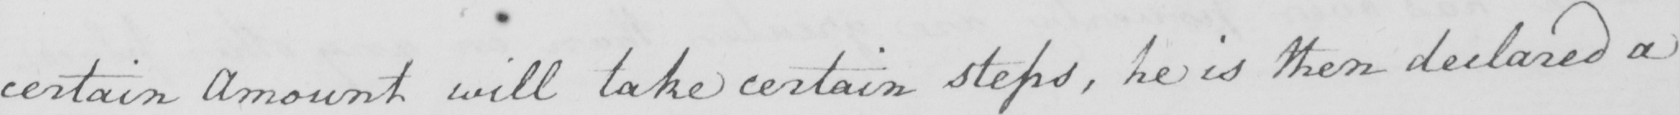What does this handwritten line say? certain Amount will take certain steps , he is then declared a 